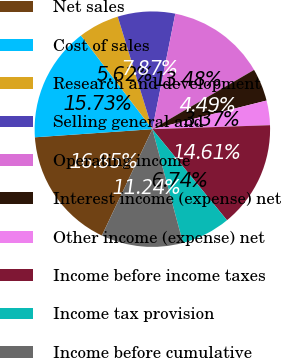Convert chart. <chart><loc_0><loc_0><loc_500><loc_500><pie_chart><fcel>Net sales<fcel>Cost of sales<fcel>Research and development<fcel>Selling general and<fcel>Operating income<fcel>Interest income (expense) net<fcel>Other income (expense) net<fcel>Income before income taxes<fcel>Income tax provision<fcel>Income before cumulative<nl><fcel>16.85%<fcel>15.73%<fcel>5.62%<fcel>7.87%<fcel>13.48%<fcel>4.49%<fcel>3.37%<fcel>14.61%<fcel>6.74%<fcel>11.24%<nl></chart> 